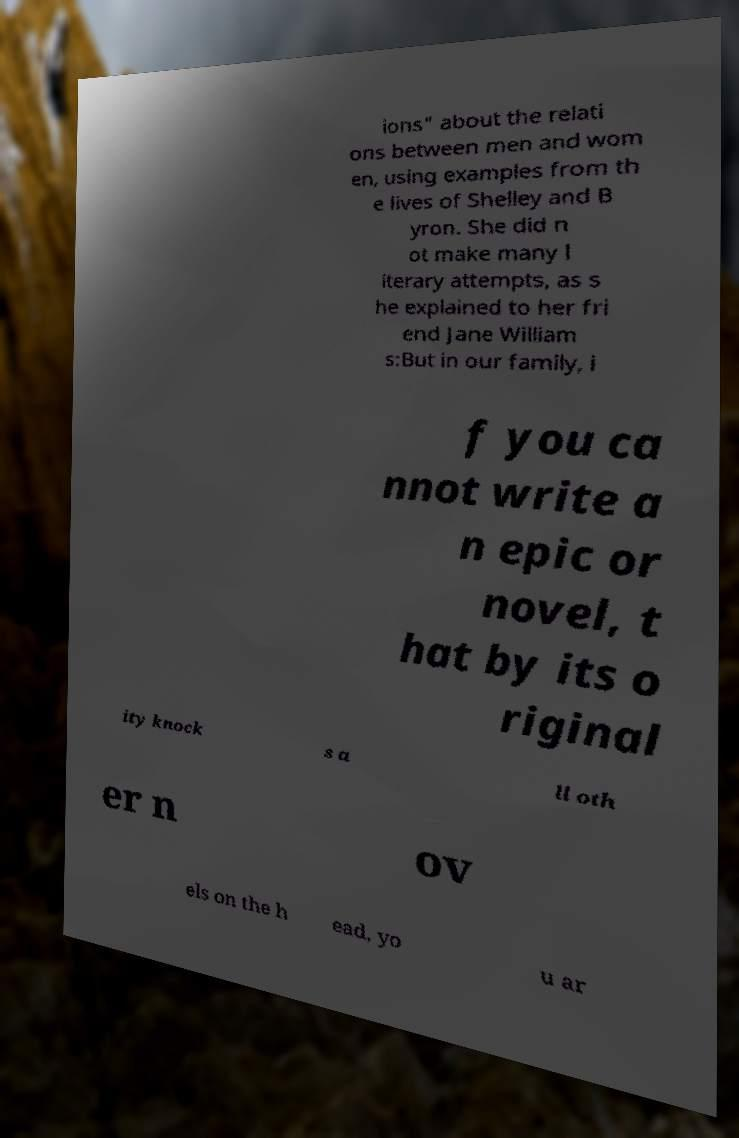There's text embedded in this image that I need extracted. Can you transcribe it verbatim? ions" about the relati ons between men and wom en, using examples from th e lives of Shelley and B yron. She did n ot make many l iterary attempts, as s he explained to her fri end Jane William s:But in our family, i f you ca nnot write a n epic or novel, t hat by its o riginal ity knock s a ll oth er n ov els on the h ead, yo u ar 